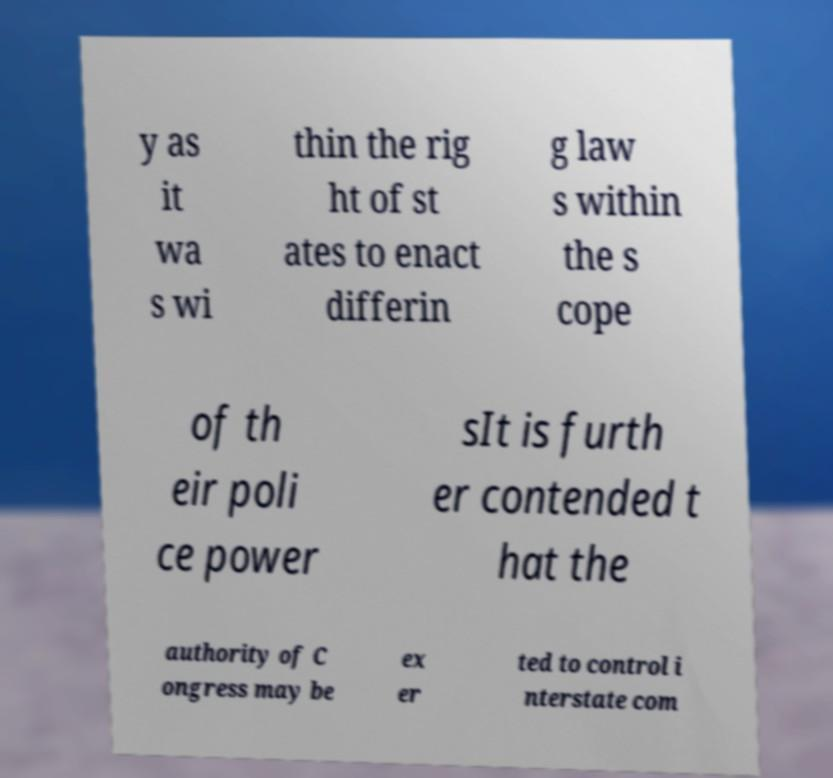Please identify and transcribe the text found in this image. y as it wa s wi thin the rig ht of st ates to enact differin g law s within the s cope of th eir poli ce power sIt is furth er contended t hat the authority of C ongress may be ex er ted to control i nterstate com 